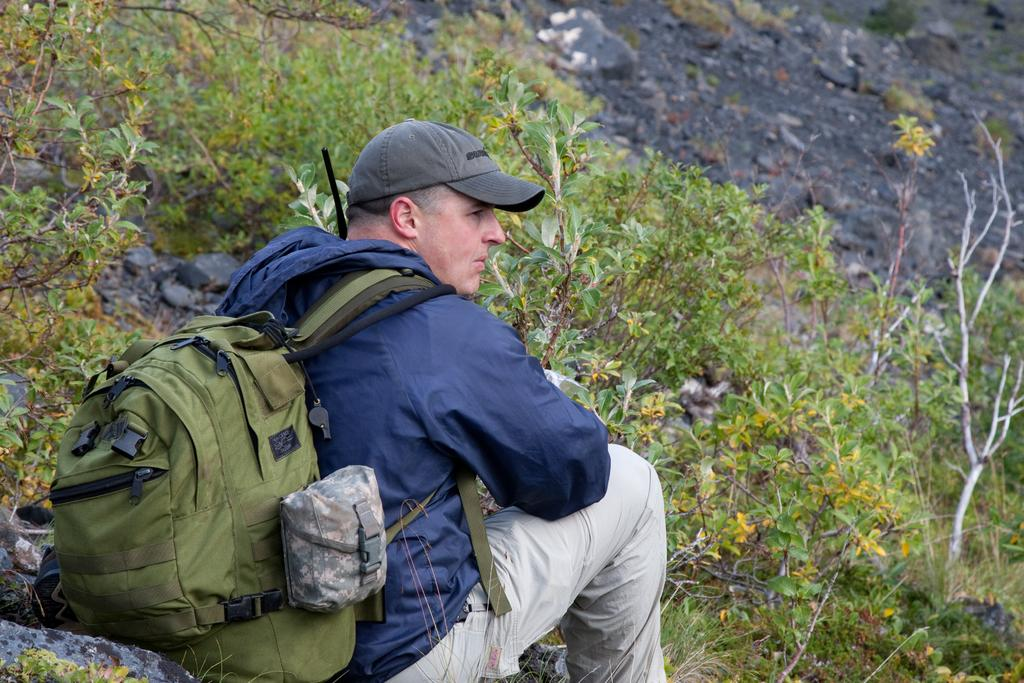What is present in the image besides the man? There are plants in the image. What is the man carrying in the image? The man is carrying a backpack. What type of headwear is the man wearing? The man is wearing a cap. What color is the jacket the man is wearing? The man is wearing a blue color jacket. Can you tell me how many horses are present in the image? There are no horses present in the image. What type of sand can be seen in the image? There is no sand present in the image. 